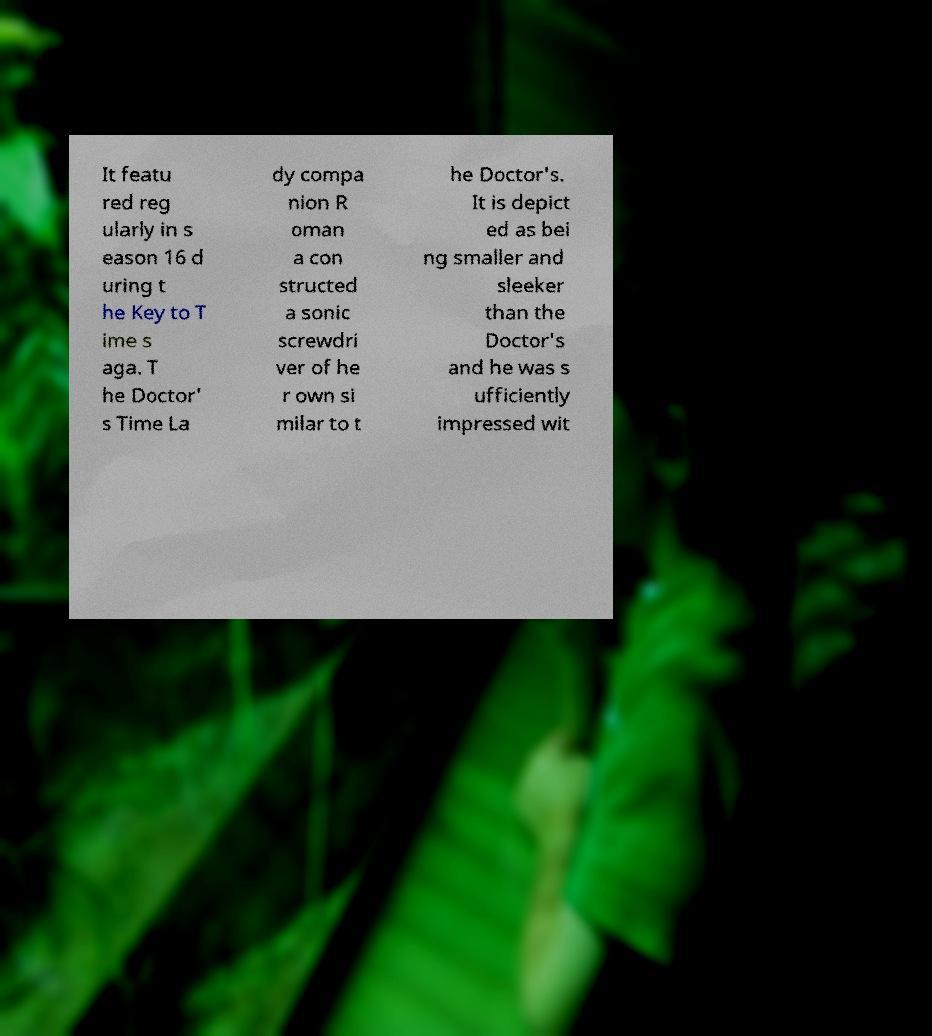Can you accurately transcribe the text from the provided image for me? It featu red reg ularly in s eason 16 d uring t he Key to T ime s aga. T he Doctor' s Time La dy compa nion R oman a con structed a sonic screwdri ver of he r own si milar to t he Doctor's. It is depict ed as bei ng smaller and sleeker than the Doctor's and he was s ufficiently impressed wit 